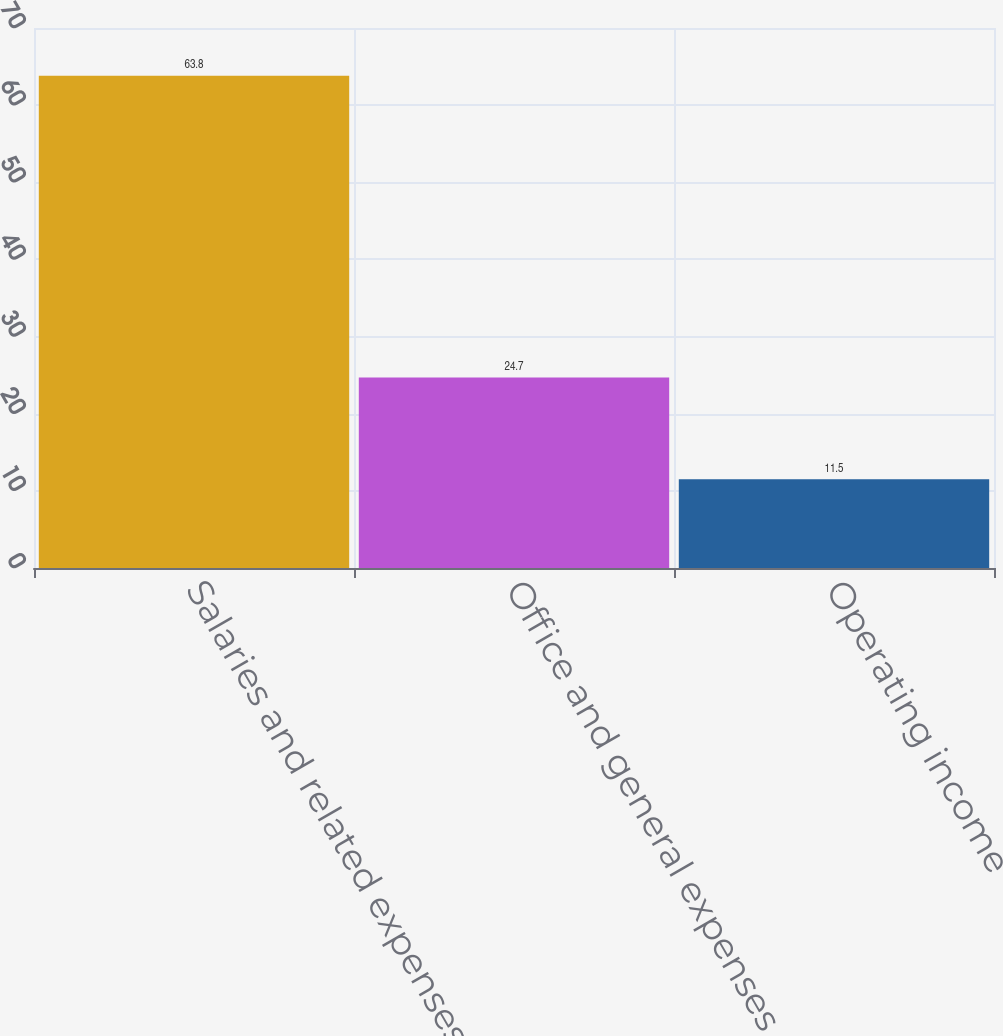Convert chart to OTSL. <chart><loc_0><loc_0><loc_500><loc_500><bar_chart><fcel>Salaries and related expenses<fcel>Office and general expenses<fcel>Operating income<nl><fcel>63.8<fcel>24.7<fcel>11.5<nl></chart> 